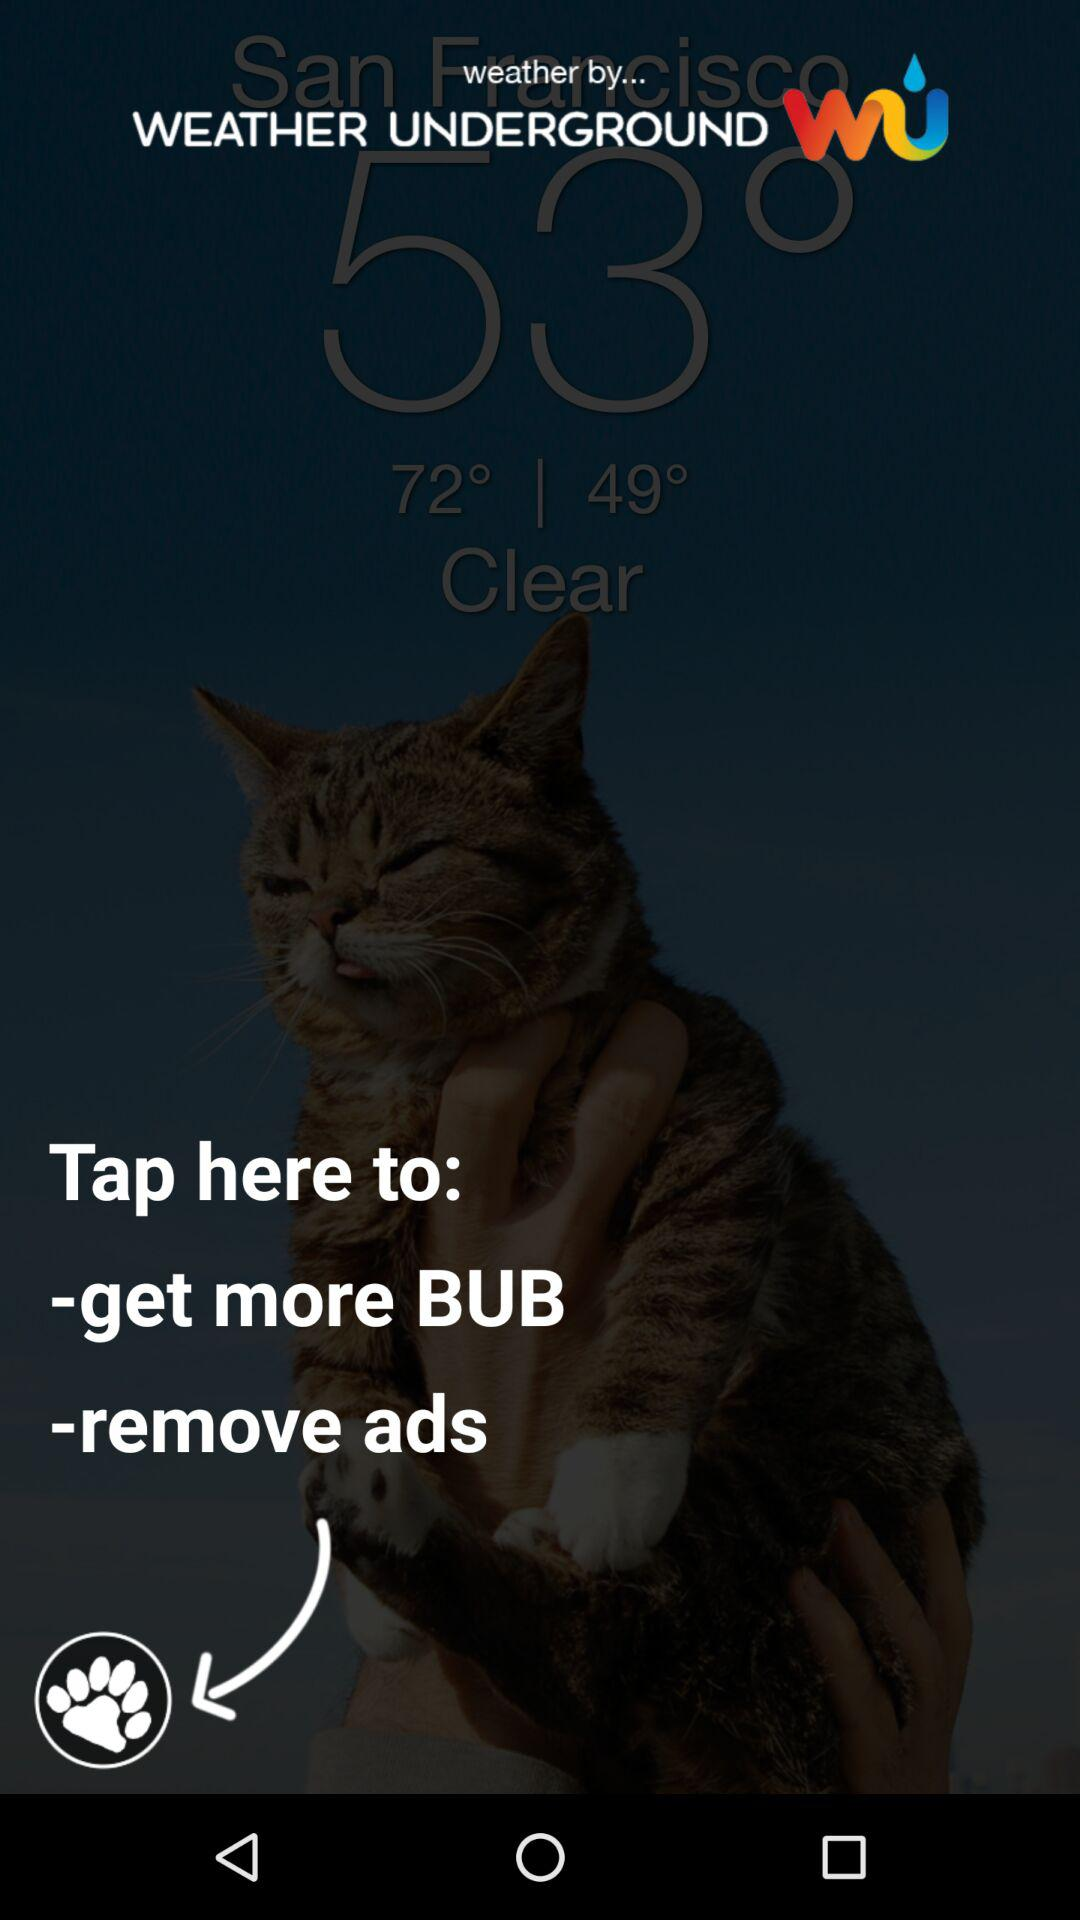How many degrees is the difference between the high and low temperature?
Answer the question using a single word or phrase. 23 